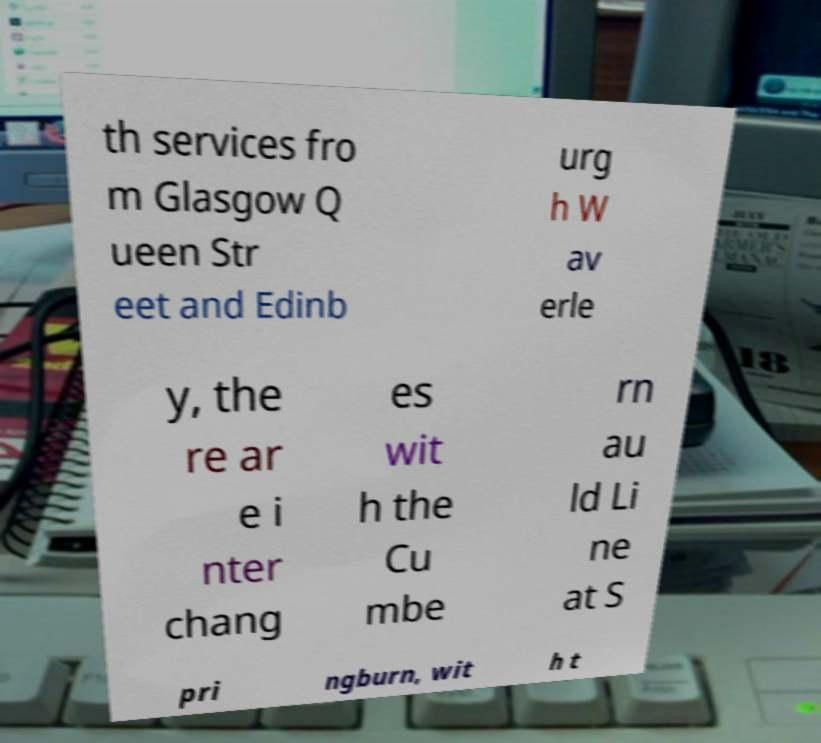Could you extract and type out the text from this image? th services fro m Glasgow Q ueen Str eet and Edinb urg h W av erle y, the re ar e i nter chang es wit h the Cu mbe rn au ld Li ne at S pri ngburn, wit h t 